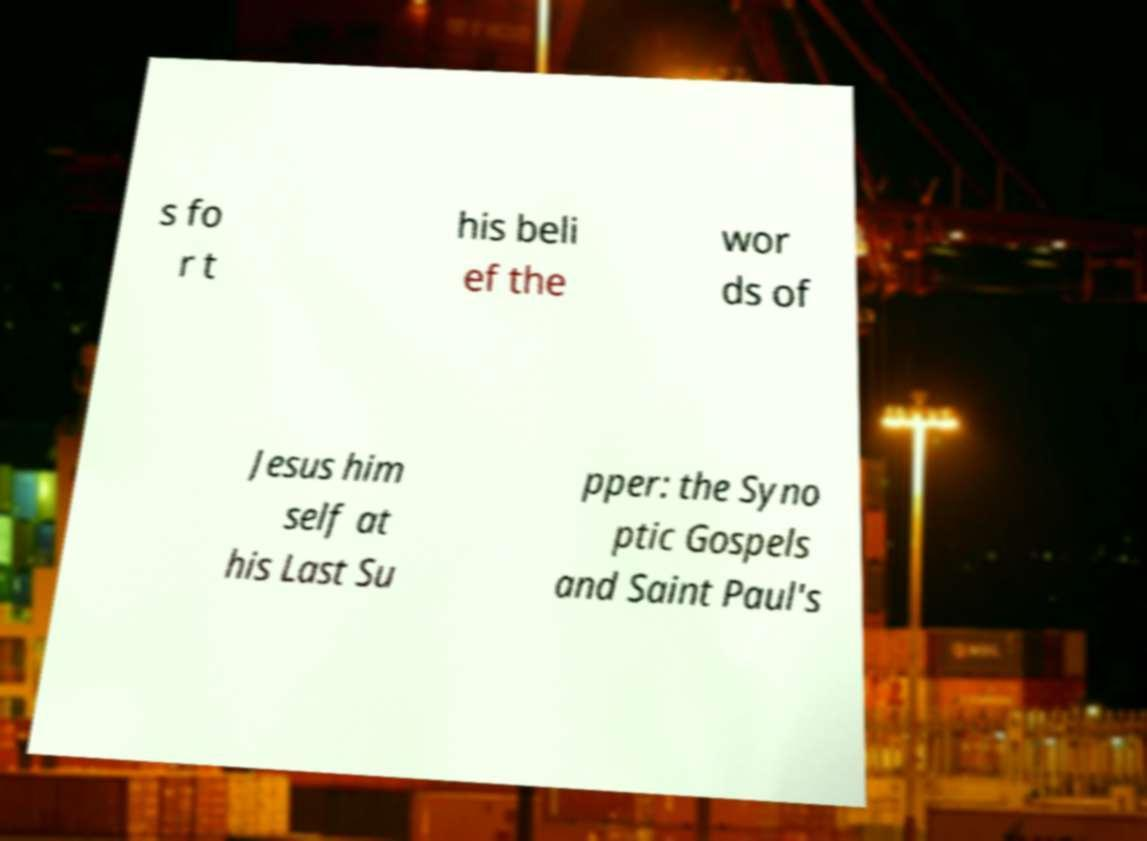Can you read and provide the text displayed in the image?This photo seems to have some interesting text. Can you extract and type it out for me? s fo r t his beli ef the wor ds of Jesus him self at his Last Su pper: the Syno ptic Gospels and Saint Paul's 